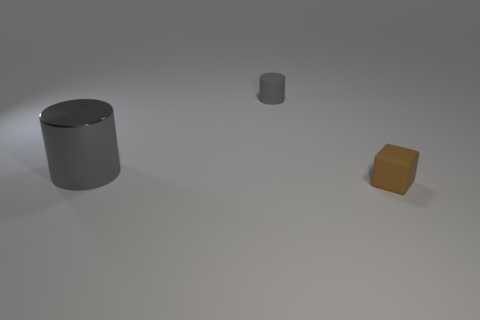How many gray cylinders must be subtracted to get 1 gray cylinders? 1 Add 3 small brown matte objects. How many objects exist? 6 Subtract 1 blocks. How many blocks are left? 0 Add 1 large things. How many large things exist? 2 Subtract 0 red blocks. How many objects are left? 3 Subtract all blocks. How many objects are left? 2 Subtract all yellow cylinders. Subtract all gray spheres. How many cylinders are left? 2 Subtract all yellow matte cylinders. Subtract all brown objects. How many objects are left? 2 Add 1 large gray metallic cylinders. How many large gray metallic cylinders are left? 2 